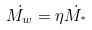Convert formula to latex. <formula><loc_0><loc_0><loc_500><loc_500>\dot { M _ { w } } = \eta \dot { M _ { ^ { * } } }</formula> 